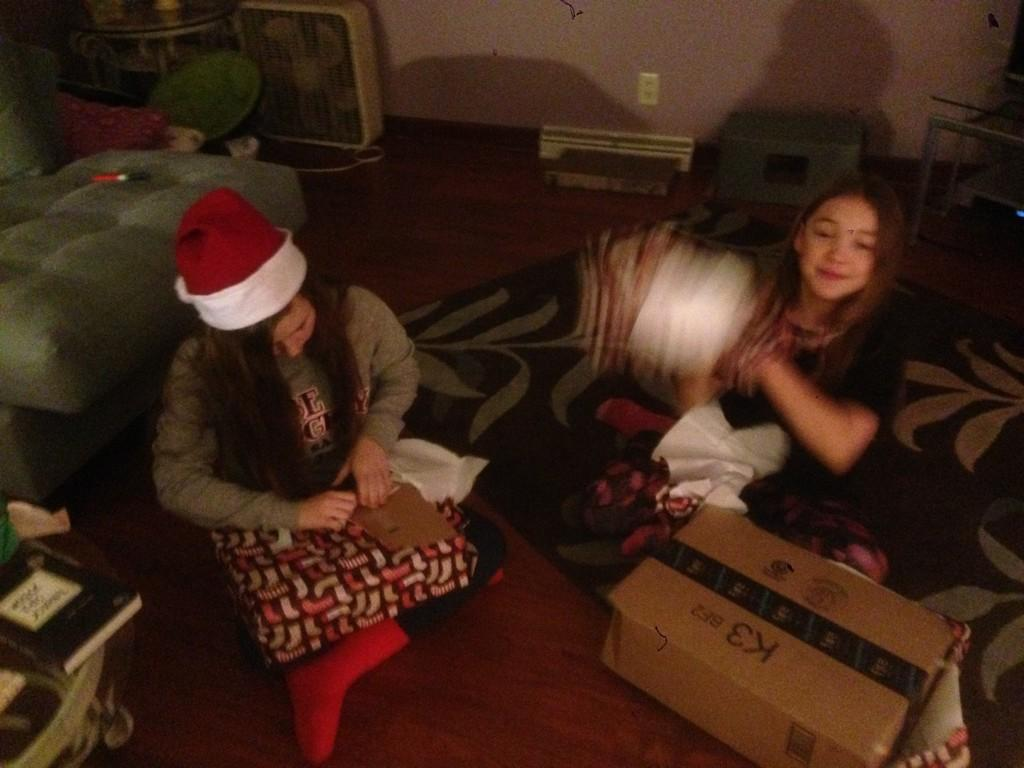How many people are sitting on the floor in the image? There are two persons sitting on the floor in the image. What type of furniture is visible in the image? There is a sofa in the image. What object can be seen in the image besides the sofa and the persons on the floor? There is a box in the image. What can be seen in the background of the image? There is a wall and a book in the background of the image. What type of cake is being offered to the persons sitting on the floor in the image? There is no cake present in the image; it only features two persons sitting on the floor, a sofa, a box, a wall, and a book in the background. 